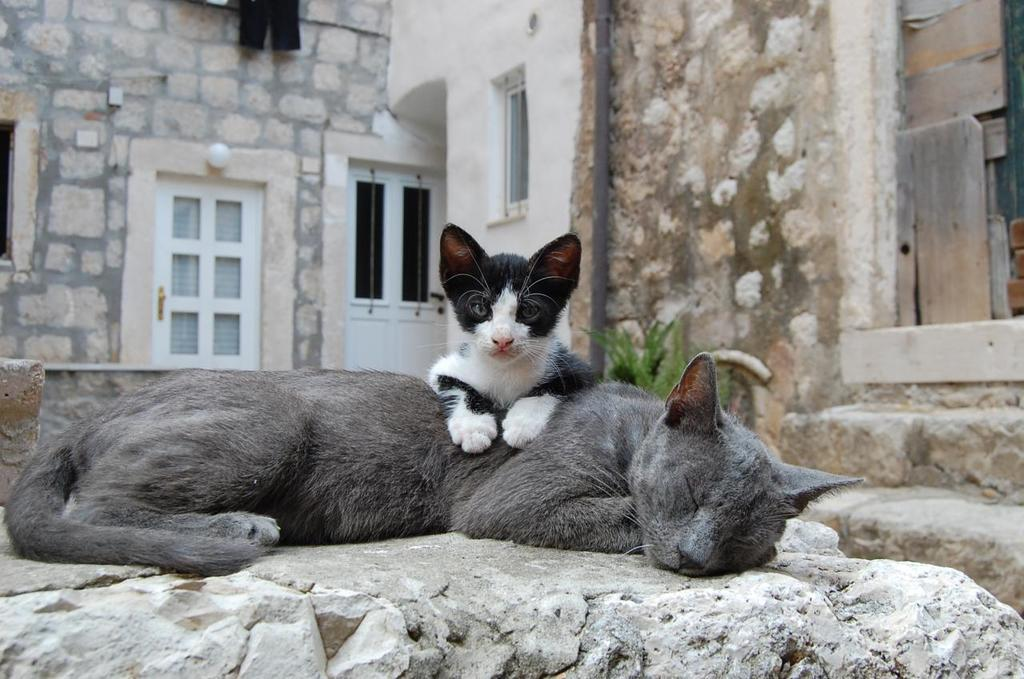How many cats are in the image? There are two cats in the image. What can be seen in the background of the image? In the background of the image, there is a wall, a door, windows, a pole, a light, and a plant. Can you describe the pole in the background? The pole in the background is a vertical structure, likely used for support or hanging objects. What type of light is visible in the background? The light in the background is an illumination source, possibly a lamp or ceiling light. What type of van can be seen parked on top of the pole in the image? There is no van present in the image, and the pole does not have a van parked on it. 